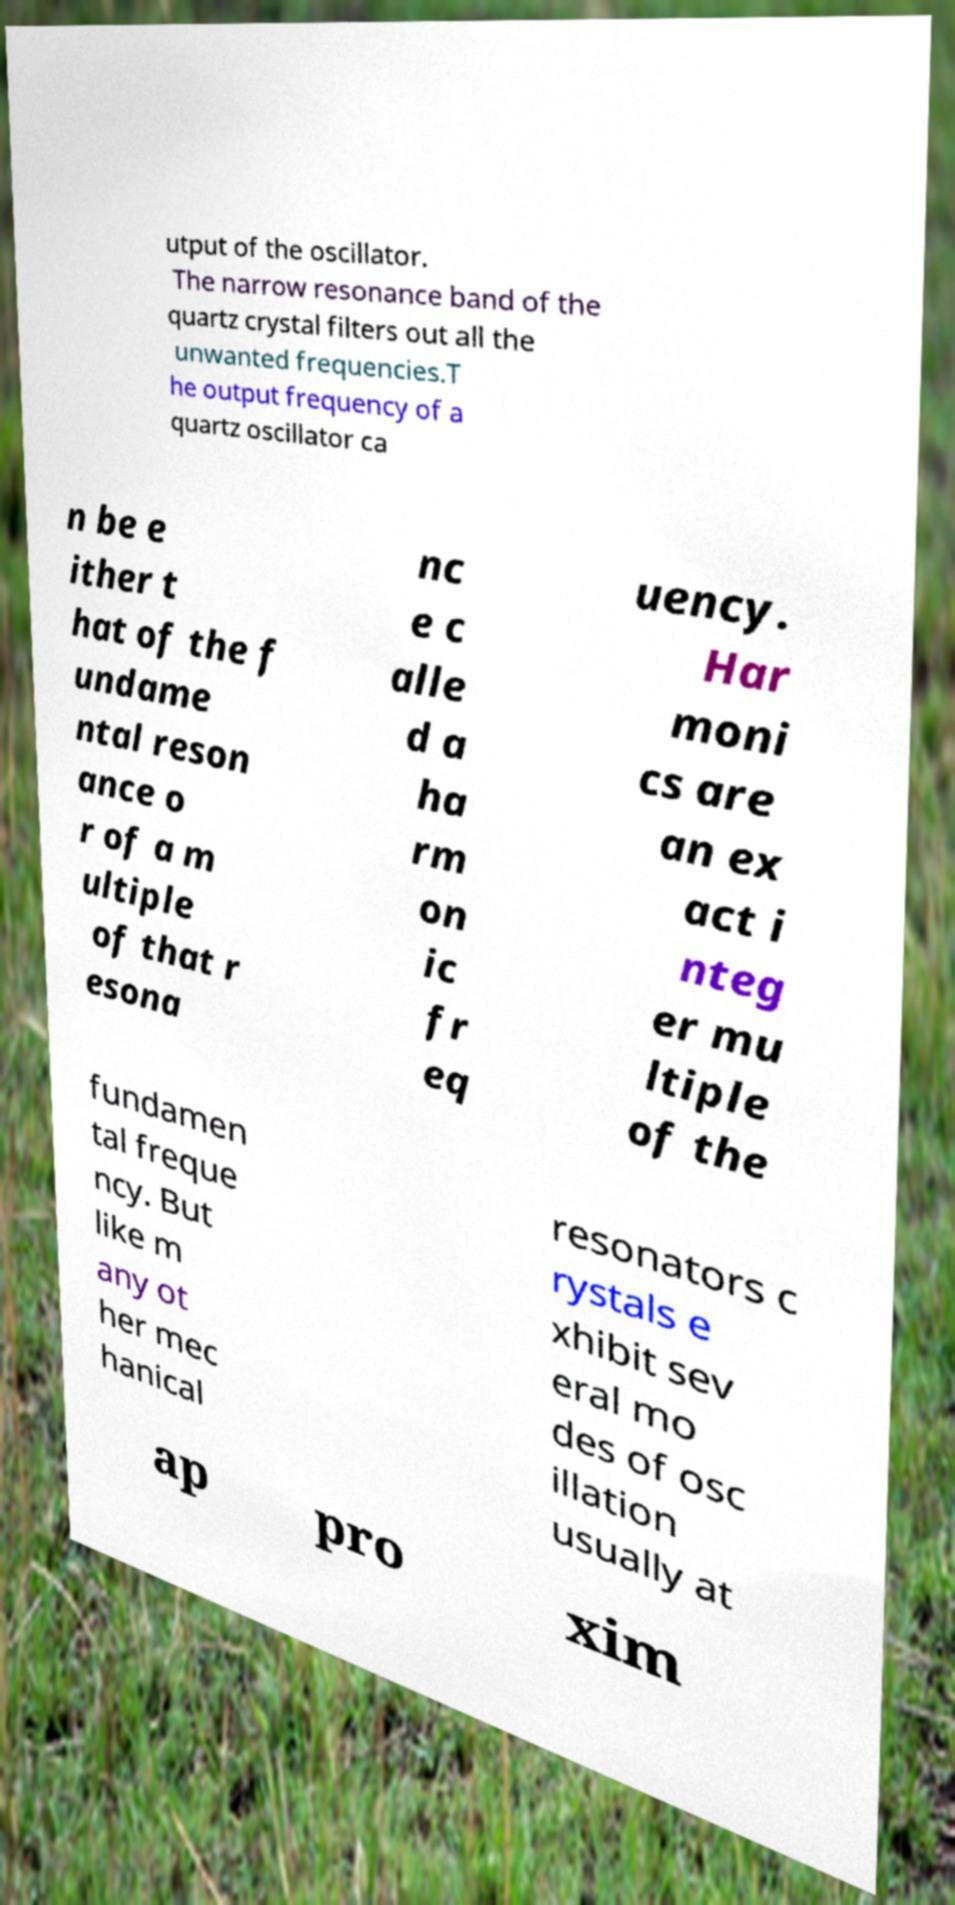Can you read and provide the text displayed in the image?This photo seems to have some interesting text. Can you extract and type it out for me? utput of the oscillator. The narrow resonance band of the quartz crystal filters out all the unwanted frequencies.T he output frequency of a quartz oscillator ca n be e ither t hat of the f undame ntal reson ance o r of a m ultiple of that r esona nc e c alle d a ha rm on ic fr eq uency. Har moni cs are an ex act i nteg er mu ltiple of the fundamen tal freque ncy. But like m any ot her mec hanical resonators c rystals e xhibit sev eral mo des of osc illation usually at ap pro xim 